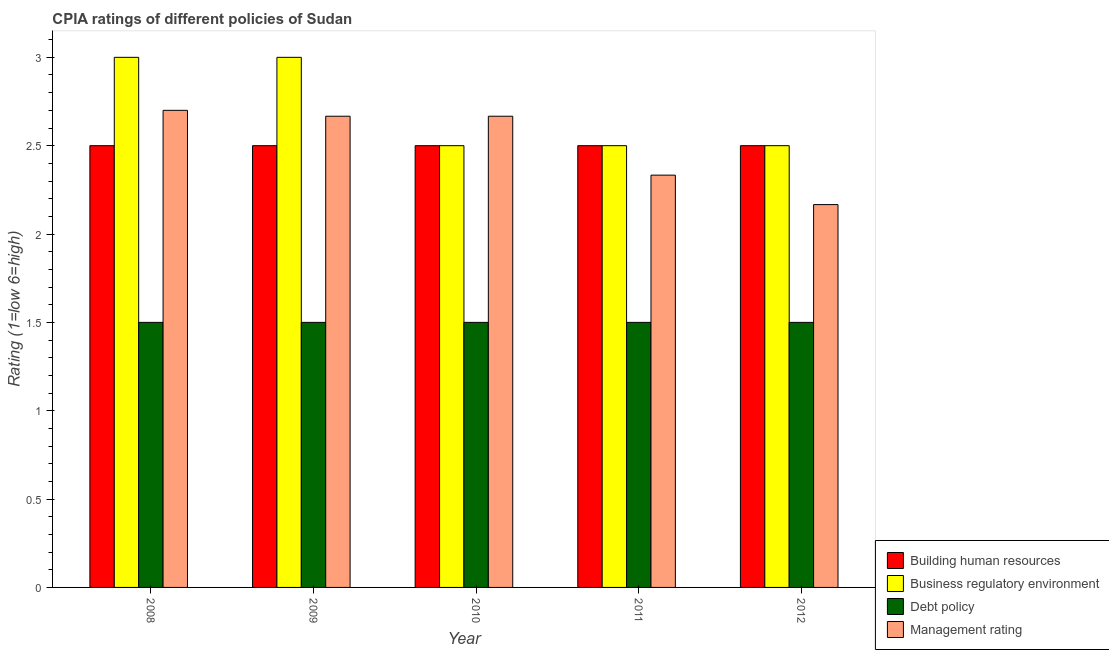How many groups of bars are there?
Your answer should be very brief. 5. Are the number of bars per tick equal to the number of legend labels?
Provide a succinct answer. Yes. How many bars are there on the 5th tick from the left?
Your answer should be compact. 4. What is the label of the 3rd group of bars from the left?
Your answer should be compact. 2010. In how many cases, is the number of bars for a given year not equal to the number of legend labels?
Provide a short and direct response. 0. Across all years, what is the maximum cpia rating of management?
Give a very brief answer. 2.7. Across all years, what is the minimum cpia rating of debt policy?
Make the answer very short. 1.5. In which year was the cpia rating of debt policy maximum?
Offer a very short reply. 2008. What is the total cpia rating of debt policy in the graph?
Your answer should be very brief. 7.5. What is the difference between the cpia rating of management in 2010 and that in 2012?
Provide a succinct answer. 0.5. What is the average cpia rating of building human resources per year?
Keep it short and to the point. 2.5. What is the ratio of the cpia rating of building human resources in 2008 to that in 2010?
Make the answer very short. 1. What is the difference between the highest and the second highest cpia rating of business regulatory environment?
Offer a very short reply. 0. What is the difference between the highest and the lowest cpia rating of building human resources?
Provide a short and direct response. 0. In how many years, is the cpia rating of debt policy greater than the average cpia rating of debt policy taken over all years?
Give a very brief answer. 0. Is the sum of the cpia rating of management in 2010 and 2011 greater than the maximum cpia rating of debt policy across all years?
Keep it short and to the point. Yes. Is it the case that in every year, the sum of the cpia rating of business regulatory environment and cpia rating of building human resources is greater than the sum of cpia rating of management and cpia rating of debt policy?
Give a very brief answer. Yes. What does the 4th bar from the left in 2011 represents?
Your answer should be very brief. Management rating. What does the 4th bar from the right in 2012 represents?
Provide a short and direct response. Building human resources. What is the title of the graph?
Make the answer very short. CPIA ratings of different policies of Sudan. Does "Ease of arranging shipments" appear as one of the legend labels in the graph?
Your answer should be very brief. No. What is the label or title of the Y-axis?
Provide a succinct answer. Rating (1=low 6=high). What is the Rating (1=low 6=high) of Building human resources in 2008?
Offer a terse response. 2.5. What is the Rating (1=low 6=high) in Management rating in 2009?
Keep it short and to the point. 2.67. What is the Rating (1=low 6=high) in Building human resources in 2010?
Your answer should be very brief. 2.5. What is the Rating (1=low 6=high) in Business regulatory environment in 2010?
Your answer should be compact. 2.5. What is the Rating (1=low 6=high) of Management rating in 2010?
Give a very brief answer. 2.67. What is the Rating (1=low 6=high) of Building human resources in 2011?
Offer a terse response. 2.5. What is the Rating (1=low 6=high) of Management rating in 2011?
Keep it short and to the point. 2.33. What is the Rating (1=low 6=high) in Building human resources in 2012?
Make the answer very short. 2.5. What is the Rating (1=low 6=high) in Debt policy in 2012?
Keep it short and to the point. 1.5. What is the Rating (1=low 6=high) in Management rating in 2012?
Make the answer very short. 2.17. Across all years, what is the maximum Rating (1=low 6=high) in Business regulatory environment?
Your response must be concise. 3. Across all years, what is the maximum Rating (1=low 6=high) in Debt policy?
Provide a short and direct response. 1.5. Across all years, what is the minimum Rating (1=low 6=high) in Business regulatory environment?
Offer a terse response. 2.5. Across all years, what is the minimum Rating (1=low 6=high) of Debt policy?
Offer a very short reply. 1.5. Across all years, what is the minimum Rating (1=low 6=high) of Management rating?
Your response must be concise. 2.17. What is the total Rating (1=low 6=high) in Building human resources in the graph?
Keep it short and to the point. 12.5. What is the total Rating (1=low 6=high) in Debt policy in the graph?
Offer a very short reply. 7.5. What is the total Rating (1=low 6=high) of Management rating in the graph?
Offer a terse response. 12.53. What is the difference between the Rating (1=low 6=high) in Building human resources in 2008 and that in 2009?
Make the answer very short. 0. What is the difference between the Rating (1=low 6=high) of Management rating in 2008 and that in 2009?
Ensure brevity in your answer.  0.03. What is the difference between the Rating (1=low 6=high) of Building human resources in 2008 and that in 2010?
Ensure brevity in your answer.  0. What is the difference between the Rating (1=low 6=high) of Debt policy in 2008 and that in 2010?
Provide a succinct answer. 0. What is the difference between the Rating (1=low 6=high) in Management rating in 2008 and that in 2011?
Your answer should be very brief. 0.37. What is the difference between the Rating (1=low 6=high) of Management rating in 2008 and that in 2012?
Provide a succinct answer. 0.53. What is the difference between the Rating (1=low 6=high) of Business regulatory environment in 2009 and that in 2010?
Make the answer very short. 0.5. What is the difference between the Rating (1=low 6=high) of Debt policy in 2009 and that in 2010?
Ensure brevity in your answer.  0. What is the difference between the Rating (1=low 6=high) of Debt policy in 2009 and that in 2011?
Your response must be concise. 0. What is the difference between the Rating (1=low 6=high) of Business regulatory environment in 2009 and that in 2012?
Keep it short and to the point. 0.5. What is the difference between the Rating (1=low 6=high) of Management rating in 2009 and that in 2012?
Your answer should be compact. 0.5. What is the difference between the Rating (1=low 6=high) in Building human resources in 2010 and that in 2011?
Ensure brevity in your answer.  0. What is the difference between the Rating (1=low 6=high) of Debt policy in 2010 and that in 2011?
Your answer should be very brief. 0. What is the difference between the Rating (1=low 6=high) of Building human resources in 2010 and that in 2012?
Your response must be concise. 0. What is the difference between the Rating (1=low 6=high) in Business regulatory environment in 2010 and that in 2012?
Keep it short and to the point. 0. What is the difference between the Rating (1=low 6=high) in Debt policy in 2010 and that in 2012?
Your response must be concise. 0. What is the difference between the Rating (1=low 6=high) in Building human resources in 2011 and that in 2012?
Keep it short and to the point. 0. What is the difference between the Rating (1=low 6=high) of Business regulatory environment in 2011 and that in 2012?
Make the answer very short. 0. What is the difference between the Rating (1=low 6=high) in Management rating in 2011 and that in 2012?
Offer a very short reply. 0.17. What is the difference between the Rating (1=low 6=high) in Business regulatory environment in 2008 and the Rating (1=low 6=high) in Management rating in 2009?
Your answer should be very brief. 0.33. What is the difference between the Rating (1=low 6=high) in Debt policy in 2008 and the Rating (1=low 6=high) in Management rating in 2009?
Offer a terse response. -1.17. What is the difference between the Rating (1=low 6=high) in Building human resources in 2008 and the Rating (1=low 6=high) in Management rating in 2010?
Your answer should be compact. -0.17. What is the difference between the Rating (1=low 6=high) of Business regulatory environment in 2008 and the Rating (1=low 6=high) of Debt policy in 2010?
Provide a short and direct response. 1.5. What is the difference between the Rating (1=low 6=high) of Business regulatory environment in 2008 and the Rating (1=low 6=high) of Management rating in 2010?
Make the answer very short. 0.33. What is the difference between the Rating (1=low 6=high) of Debt policy in 2008 and the Rating (1=low 6=high) of Management rating in 2010?
Ensure brevity in your answer.  -1.17. What is the difference between the Rating (1=low 6=high) in Business regulatory environment in 2008 and the Rating (1=low 6=high) in Debt policy in 2011?
Make the answer very short. 1.5. What is the difference between the Rating (1=low 6=high) of Business regulatory environment in 2008 and the Rating (1=low 6=high) of Management rating in 2011?
Keep it short and to the point. 0.67. What is the difference between the Rating (1=low 6=high) in Debt policy in 2008 and the Rating (1=low 6=high) in Management rating in 2011?
Provide a succinct answer. -0.83. What is the difference between the Rating (1=low 6=high) of Business regulatory environment in 2008 and the Rating (1=low 6=high) of Debt policy in 2012?
Make the answer very short. 1.5. What is the difference between the Rating (1=low 6=high) of Business regulatory environment in 2008 and the Rating (1=low 6=high) of Management rating in 2012?
Your answer should be compact. 0.83. What is the difference between the Rating (1=low 6=high) of Debt policy in 2008 and the Rating (1=low 6=high) of Management rating in 2012?
Keep it short and to the point. -0.67. What is the difference between the Rating (1=low 6=high) in Building human resources in 2009 and the Rating (1=low 6=high) in Business regulatory environment in 2010?
Your answer should be very brief. 0. What is the difference between the Rating (1=low 6=high) in Building human resources in 2009 and the Rating (1=low 6=high) in Debt policy in 2010?
Your response must be concise. 1. What is the difference between the Rating (1=low 6=high) in Debt policy in 2009 and the Rating (1=low 6=high) in Management rating in 2010?
Offer a terse response. -1.17. What is the difference between the Rating (1=low 6=high) in Building human resources in 2009 and the Rating (1=low 6=high) in Business regulatory environment in 2011?
Offer a very short reply. 0. What is the difference between the Rating (1=low 6=high) in Building human resources in 2009 and the Rating (1=low 6=high) in Debt policy in 2011?
Ensure brevity in your answer.  1. What is the difference between the Rating (1=low 6=high) in Business regulatory environment in 2009 and the Rating (1=low 6=high) in Debt policy in 2011?
Give a very brief answer. 1.5. What is the difference between the Rating (1=low 6=high) of Business regulatory environment in 2009 and the Rating (1=low 6=high) of Management rating in 2011?
Your response must be concise. 0.67. What is the difference between the Rating (1=low 6=high) of Building human resources in 2009 and the Rating (1=low 6=high) of Debt policy in 2012?
Ensure brevity in your answer.  1. What is the difference between the Rating (1=low 6=high) in Building human resources in 2009 and the Rating (1=low 6=high) in Management rating in 2012?
Give a very brief answer. 0.33. What is the difference between the Rating (1=low 6=high) in Business regulatory environment in 2009 and the Rating (1=low 6=high) in Debt policy in 2012?
Provide a succinct answer. 1.5. What is the difference between the Rating (1=low 6=high) of Building human resources in 2010 and the Rating (1=low 6=high) of Business regulatory environment in 2011?
Your answer should be very brief. 0. What is the difference between the Rating (1=low 6=high) of Business regulatory environment in 2010 and the Rating (1=low 6=high) of Debt policy in 2011?
Your answer should be very brief. 1. What is the difference between the Rating (1=low 6=high) in Debt policy in 2010 and the Rating (1=low 6=high) in Management rating in 2011?
Provide a succinct answer. -0.83. What is the difference between the Rating (1=low 6=high) in Building human resources in 2010 and the Rating (1=low 6=high) in Business regulatory environment in 2012?
Offer a very short reply. 0. What is the difference between the Rating (1=low 6=high) in Business regulatory environment in 2010 and the Rating (1=low 6=high) in Debt policy in 2012?
Your answer should be compact. 1. What is the difference between the Rating (1=low 6=high) of Business regulatory environment in 2010 and the Rating (1=low 6=high) of Management rating in 2012?
Provide a short and direct response. 0.33. What is the difference between the Rating (1=low 6=high) of Debt policy in 2010 and the Rating (1=low 6=high) of Management rating in 2012?
Provide a succinct answer. -0.67. What is the difference between the Rating (1=low 6=high) in Building human resources in 2011 and the Rating (1=low 6=high) in Business regulatory environment in 2012?
Ensure brevity in your answer.  0. What is the difference between the Rating (1=low 6=high) of Building human resources in 2011 and the Rating (1=low 6=high) of Management rating in 2012?
Keep it short and to the point. 0.33. What is the difference between the Rating (1=low 6=high) of Debt policy in 2011 and the Rating (1=low 6=high) of Management rating in 2012?
Your answer should be very brief. -0.67. What is the average Rating (1=low 6=high) in Building human resources per year?
Ensure brevity in your answer.  2.5. What is the average Rating (1=low 6=high) in Business regulatory environment per year?
Keep it short and to the point. 2.7. What is the average Rating (1=low 6=high) of Management rating per year?
Give a very brief answer. 2.51. In the year 2008, what is the difference between the Rating (1=low 6=high) in Debt policy and Rating (1=low 6=high) in Management rating?
Your answer should be compact. -1.2. In the year 2009, what is the difference between the Rating (1=low 6=high) in Building human resources and Rating (1=low 6=high) in Business regulatory environment?
Your response must be concise. -0.5. In the year 2009, what is the difference between the Rating (1=low 6=high) in Debt policy and Rating (1=low 6=high) in Management rating?
Provide a succinct answer. -1.17. In the year 2010, what is the difference between the Rating (1=low 6=high) of Building human resources and Rating (1=low 6=high) of Management rating?
Make the answer very short. -0.17. In the year 2010, what is the difference between the Rating (1=low 6=high) in Business regulatory environment and Rating (1=low 6=high) in Debt policy?
Offer a terse response. 1. In the year 2010, what is the difference between the Rating (1=low 6=high) in Business regulatory environment and Rating (1=low 6=high) in Management rating?
Provide a succinct answer. -0.17. In the year 2010, what is the difference between the Rating (1=low 6=high) in Debt policy and Rating (1=low 6=high) in Management rating?
Ensure brevity in your answer.  -1.17. In the year 2011, what is the difference between the Rating (1=low 6=high) in Building human resources and Rating (1=low 6=high) in Debt policy?
Offer a terse response. 1. In the year 2011, what is the difference between the Rating (1=low 6=high) of Building human resources and Rating (1=low 6=high) of Management rating?
Give a very brief answer. 0.17. In the year 2011, what is the difference between the Rating (1=low 6=high) of Business regulatory environment and Rating (1=low 6=high) of Debt policy?
Ensure brevity in your answer.  1. In the year 2011, what is the difference between the Rating (1=low 6=high) of Debt policy and Rating (1=low 6=high) of Management rating?
Provide a succinct answer. -0.83. In the year 2012, what is the difference between the Rating (1=low 6=high) of Building human resources and Rating (1=low 6=high) of Business regulatory environment?
Give a very brief answer. 0. In the year 2012, what is the difference between the Rating (1=low 6=high) in Building human resources and Rating (1=low 6=high) in Debt policy?
Provide a short and direct response. 1. In the year 2012, what is the difference between the Rating (1=low 6=high) of Business regulatory environment and Rating (1=low 6=high) of Debt policy?
Ensure brevity in your answer.  1. In the year 2012, what is the difference between the Rating (1=low 6=high) in Business regulatory environment and Rating (1=low 6=high) in Management rating?
Your answer should be very brief. 0.33. What is the ratio of the Rating (1=low 6=high) in Debt policy in 2008 to that in 2009?
Give a very brief answer. 1. What is the ratio of the Rating (1=low 6=high) in Management rating in 2008 to that in 2009?
Offer a very short reply. 1.01. What is the ratio of the Rating (1=low 6=high) in Building human resources in 2008 to that in 2010?
Provide a short and direct response. 1. What is the ratio of the Rating (1=low 6=high) of Management rating in 2008 to that in 2010?
Provide a short and direct response. 1.01. What is the ratio of the Rating (1=low 6=high) of Business regulatory environment in 2008 to that in 2011?
Provide a short and direct response. 1.2. What is the ratio of the Rating (1=low 6=high) in Debt policy in 2008 to that in 2011?
Your answer should be very brief. 1. What is the ratio of the Rating (1=low 6=high) in Management rating in 2008 to that in 2011?
Provide a succinct answer. 1.16. What is the ratio of the Rating (1=low 6=high) of Building human resources in 2008 to that in 2012?
Your answer should be very brief. 1. What is the ratio of the Rating (1=low 6=high) of Business regulatory environment in 2008 to that in 2012?
Give a very brief answer. 1.2. What is the ratio of the Rating (1=low 6=high) in Debt policy in 2008 to that in 2012?
Keep it short and to the point. 1. What is the ratio of the Rating (1=low 6=high) in Management rating in 2008 to that in 2012?
Give a very brief answer. 1.25. What is the ratio of the Rating (1=low 6=high) of Building human resources in 2009 to that in 2010?
Provide a short and direct response. 1. What is the ratio of the Rating (1=low 6=high) in Business regulatory environment in 2009 to that in 2010?
Provide a short and direct response. 1.2. What is the ratio of the Rating (1=low 6=high) in Building human resources in 2009 to that in 2011?
Your answer should be very brief. 1. What is the ratio of the Rating (1=low 6=high) of Business regulatory environment in 2009 to that in 2011?
Your answer should be very brief. 1.2. What is the ratio of the Rating (1=low 6=high) of Debt policy in 2009 to that in 2011?
Your answer should be compact. 1. What is the ratio of the Rating (1=low 6=high) in Debt policy in 2009 to that in 2012?
Offer a terse response. 1. What is the ratio of the Rating (1=low 6=high) in Management rating in 2009 to that in 2012?
Your answer should be compact. 1.23. What is the ratio of the Rating (1=low 6=high) in Building human resources in 2010 to that in 2011?
Ensure brevity in your answer.  1. What is the ratio of the Rating (1=low 6=high) in Business regulatory environment in 2010 to that in 2011?
Provide a short and direct response. 1. What is the ratio of the Rating (1=low 6=high) of Debt policy in 2010 to that in 2012?
Keep it short and to the point. 1. What is the ratio of the Rating (1=low 6=high) of Management rating in 2010 to that in 2012?
Provide a short and direct response. 1.23. What is the ratio of the Rating (1=low 6=high) in Building human resources in 2011 to that in 2012?
Offer a very short reply. 1. What is the ratio of the Rating (1=low 6=high) in Management rating in 2011 to that in 2012?
Offer a very short reply. 1.08. What is the difference between the highest and the second highest Rating (1=low 6=high) in Building human resources?
Keep it short and to the point. 0. What is the difference between the highest and the second highest Rating (1=low 6=high) in Business regulatory environment?
Make the answer very short. 0. What is the difference between the highest and the second highest Rating (1=low 6=high) in Management rating?
Make the answer very short. 0.03. What is the difference between the highest and the lowest Rating (1=low 6=high) in Business regulatory environment?
Ensure brevity in your answer.  0.5. What is the difference between the highest and the lowest Rating (1=low 6=high) of Debt policy?
Provide a succinct answer. 0. What is the difference between the highest and the lowest Rating (1=low 6=high) of Management rating?
Your answer should be compact. 0.53. 